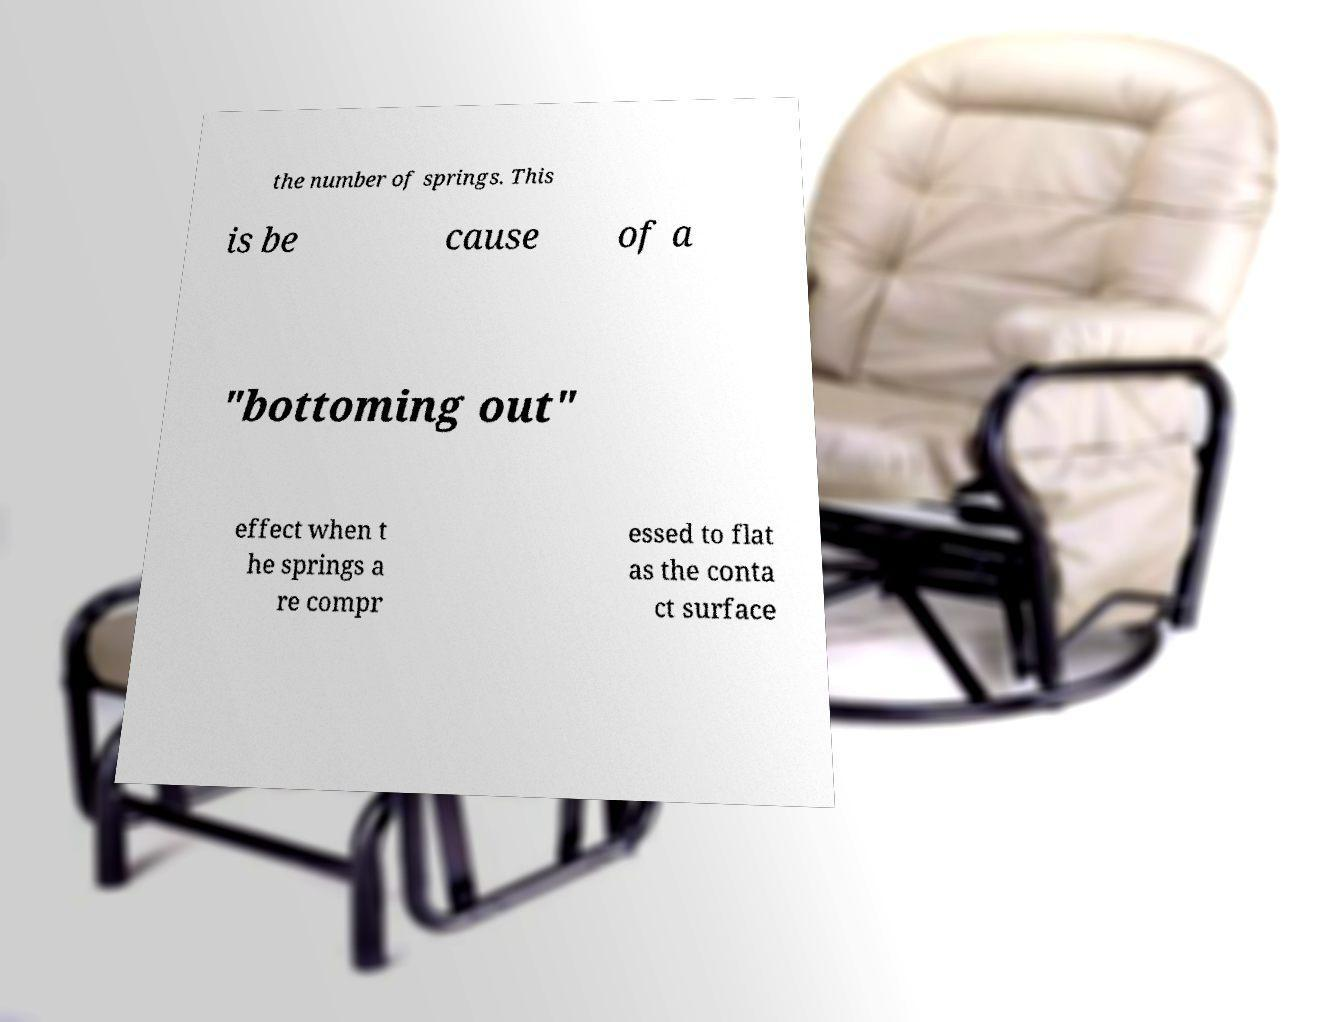What messages or text are displayed in this image? I need them in a readable, typed format. the number of springs. This is be cause of a "bottoming out" effect when t he springs a re compr essed to flat as the conta ct surface 